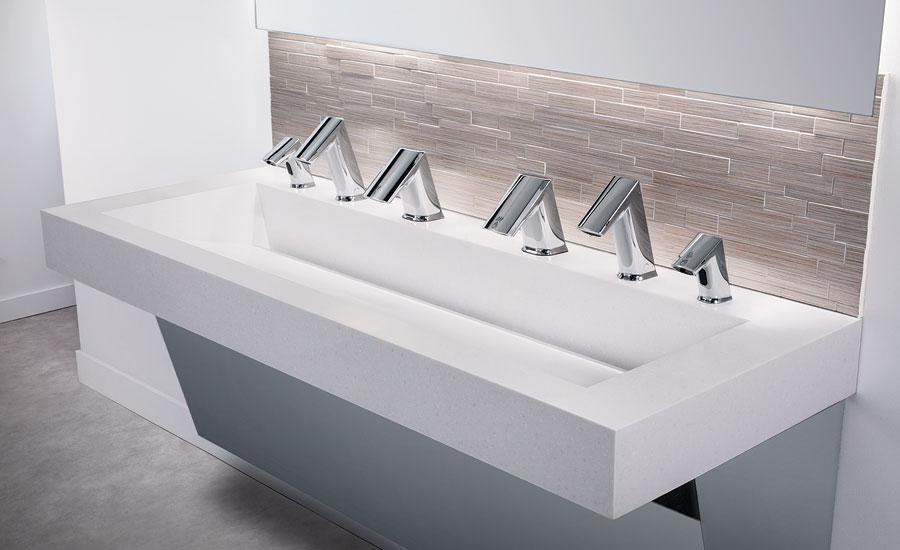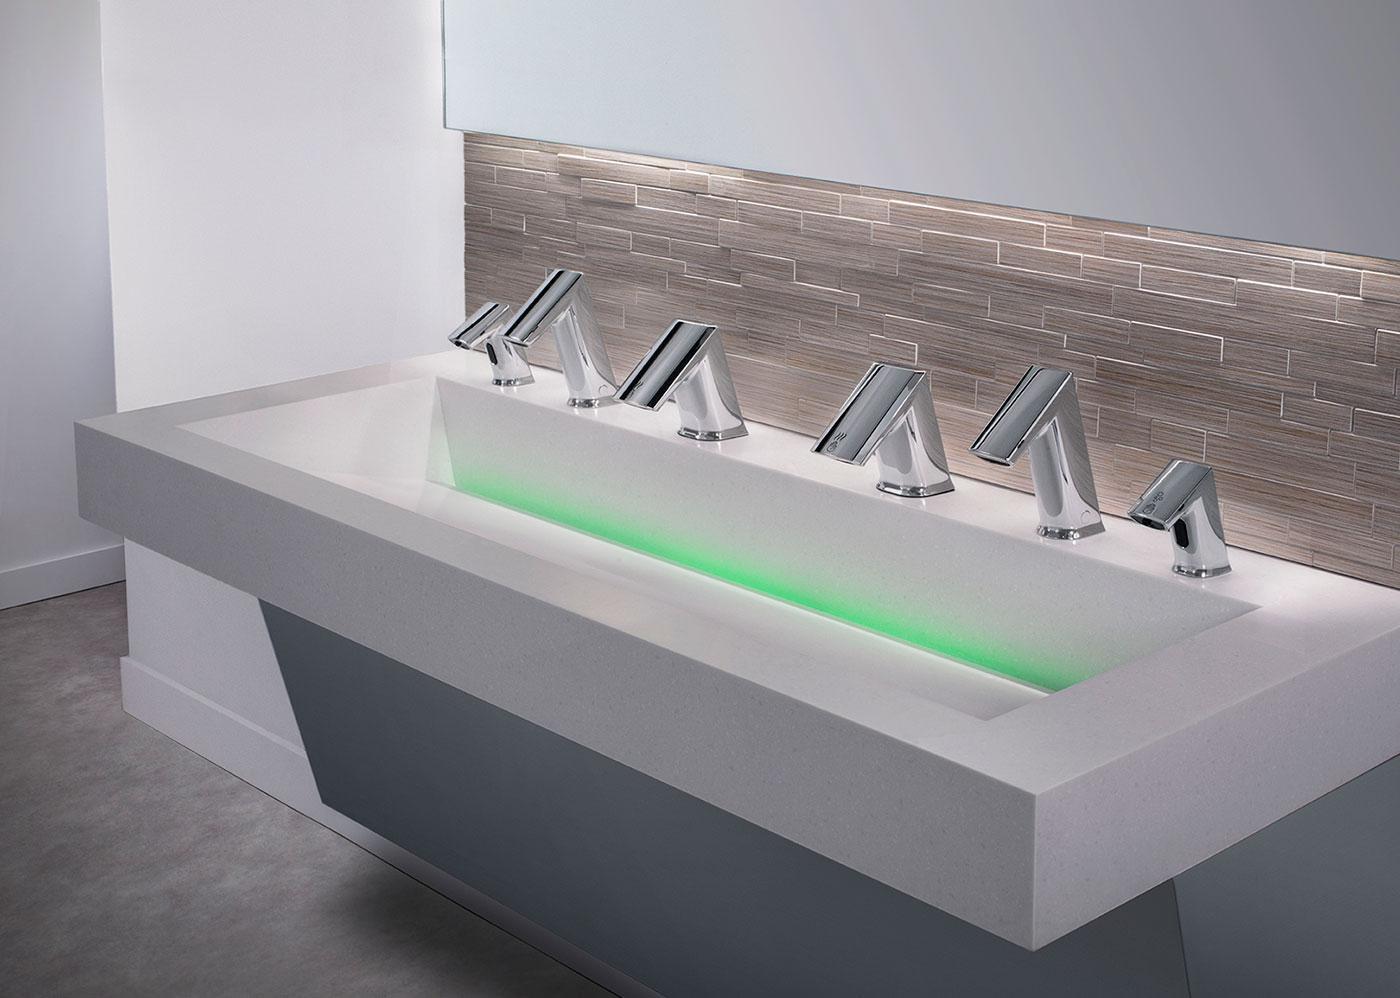The first image is the image on the left, the second image is the image on the right. For the images shown, is this caption "Each image shows a white counter with a single undivided rectangular sink carved into it, and at least one image features a row of six spouts above the basin." true? Answer yes or no. Yes. The first image is the image on the left, the second image is the image on the right. For the images displayed, is the sentence "In at least one image there is at least one floating white sink sitting on top of a grey block." factually correct? Answer yes or no. No. 